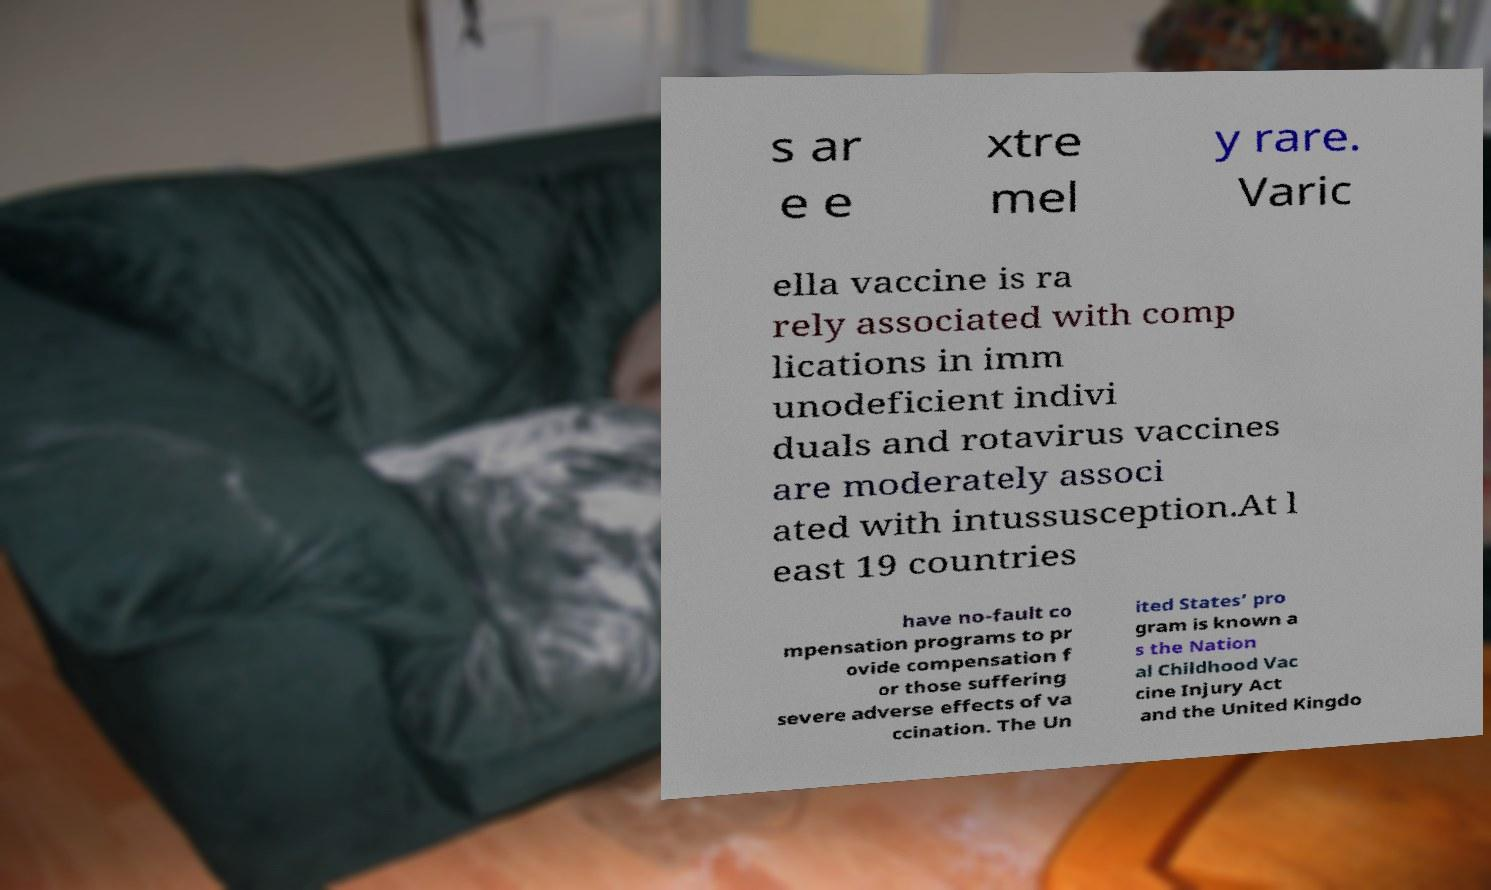What messages or text are displayed in this image? I need them in a readable, typed format. s ar e e xtre mel y rare. Varic ella vaccine is ra rely associated with comp lications in imm unodeficient indivi duals and rotavirus vaccines are moderately associ ated with intussusception.At l east 19 countries have no-fault co mpensation programs to pr ovide compensation f or those suffering severe adverse effects of va ccination. The Un ited States’ pro gram is known a s the Nation al Childhood Vac cine Injury Act and the United Kingdo 